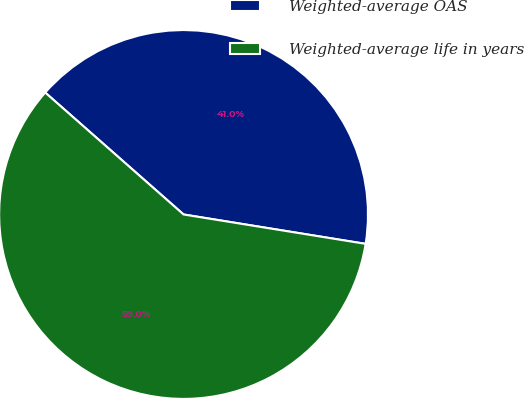Convert chart to OTSL. <chart><loc_0><loc_0><loc_500><loc_500><pie_chart><fcel>Weighted-average OAS<fcel>Weighted-average life in years<nl><fcel>41.05%<fcel>58.95%<nl></chart> 